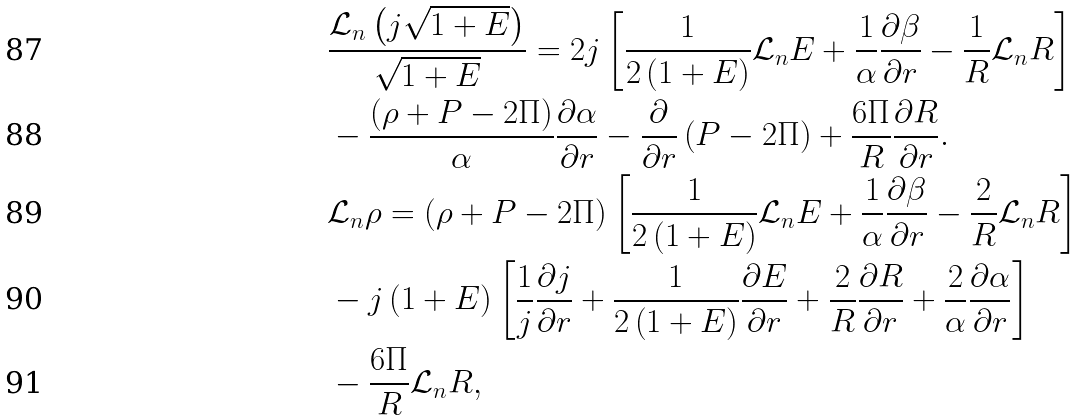<formula> <loc_0><loc_0><loc_500><loc_500>& \frac { \mathcal { L } _ { n } \left ( j \sqrt { 1 + E } \right ) } { \sqrt { 1 + E } } = 2 j \left [ \frac { 1 } { 2 \left ( 1 + E \right ) } \mathcal { L } _ { n } E + \frac { 1 } { \alpha } \frac { \partial \beta } { \partial r } - \frac { 1 } { R } \mathcal { L } _ { n } R \right ] \\ & - \frac { \left ( \rho + P - 2 \Pi \right ) } { \alpha } \frac { \partial \alpha } { \partial r } - \frac { \partial } { \partial r } \left ( P - 2 \Pi \right ) + \frac { 6 \Pi } { R } \frac { \partial R } { \partial r } . \\ & \mathcal { L } _ { n } \rho = \left ( \rho + P - 2 \Pi \right ) \left [ \frac { 1 } { 2 \left ( 1 + E \right ) } \mathcal { L } _ { n } E + \frac { 1 } { \alpha } \frac { \partial \beta } { \partial r } - \frac { 2 } { R } \mathcal { L } _ { n } R \right ] \\ & - j \left ( 1 + E \right ) \left [ \frac { 1 } { j } \frac { \partial j } { \partial r } + \frac { 1 } { 2 \left ( 1 + E \right ) } \frac { \partial E } { \partial r } + \frac { 2 } { R } \frac { \partial R } { \partial r } + \frac { 2 } { \alpha } \frac { \partial \alpha } { \partial r } \right ] \\ & - \frac { 6 \Pi } { R } \mathcal { L } _ { n } R ,</formula> 